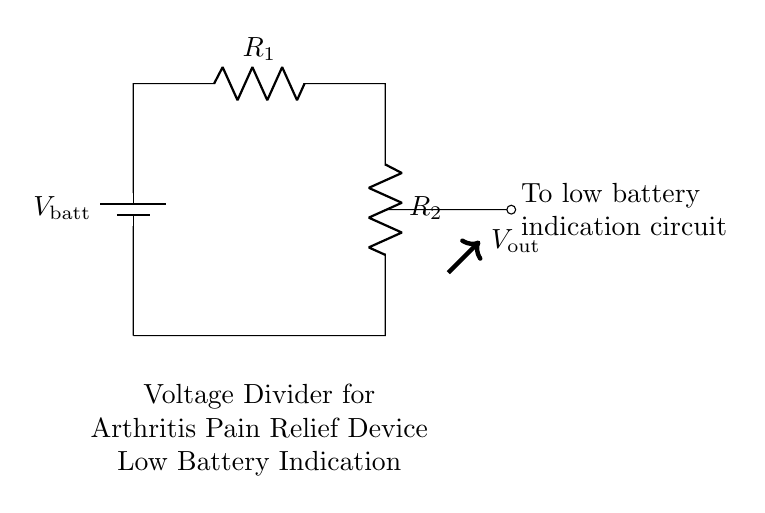What type of circuit is this? This circuit is a voltage divider, which is used to divide the input voltage into smaller output voltages based on the resistances used in the circuit.
Answer: voltage divider What are the components in this circuit? The circuit contains a battery and two resistors, labeled R1 and R2. The battery provides the input voltage, while the resistors are responsible for creating the voltage division.
Answer: battery, resistors What is the output voltage referred to in this circuit? The output voltage, labeled Vout, is the voltage measured across one of the resistors. In voltage divider circuits, it's the result of dividing the total input voltage based on the resistance values.
Answer: Vout What happens when the battery voltage decreases? As the battery voltage decreases, the output voltage will also decrease proportionally, which can trigger the low battery indication circuit if it falls below a certain threshold.
Answer: output voltage decreases How do the resistors affect the output voltage? The output voltage is determined by the ratio of the resistances. It can be calculated using the formula Vout = Vin * (R2 / (R1 + R2)), indicating that changing the resistor values changes the output voltage proportionately.
Answer: affects output voltage proportionally What is the function of this circuit in the device? The primary function of this voltage divider circuit is to provide a low battery indication, alerting the user when the battery voltage falls below a certain level, which is critical for ensuring the device continues to operate effectively.
Answer: low battery indication What is the significance of the connections between the components? The connections ensure that the battery voltage is divided across the resistors correctly, enabling the measurement of output voltage to reflect the battery's status and power levels accurately which is essential for the low battery indicator to function.
Answer: ensures proper voltage division 